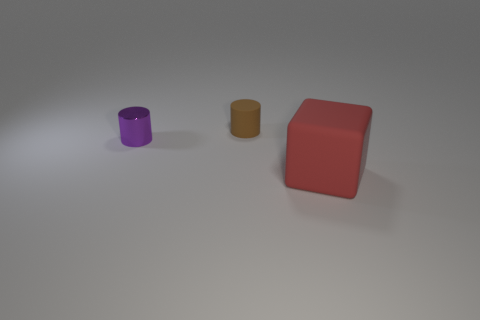Add 2 tiny gray matte blocks. How many objects exist? 5 Subtract all cylinders. How many objects are left? 1 Add 3 tiny things. How many tiny things are left? 5 Add 2 red objects. How many red objects exist? 3 Subtract 0 gray cylinders. How many objects are left? 3 Subtract all large red things. Subtract all purple metal balls. How many objects are left? 2 